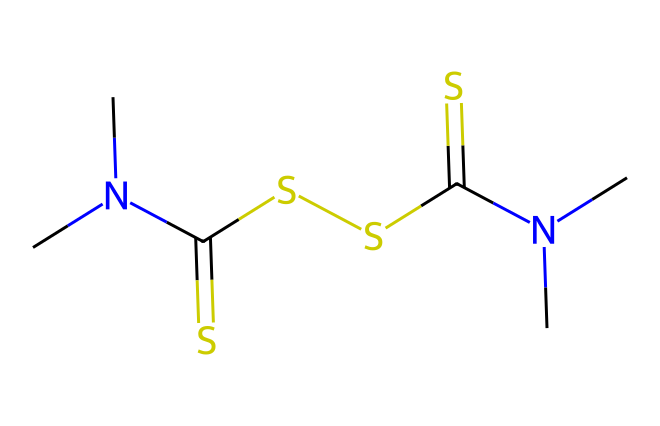What is the molecular formula of thiram? The SMILES representation can be analyzed to count the number of each type of atom present. The breakdown shows there are 8 carbon (C) atoms, 16 hydrogen (H) atoms, 4 sulfur (S) atoms, and 2 nitrogen (N) atoms. Putting this together, the molecular formula is C8H16N2S4.
Answer: C8H16N2S4 How many sulfur atoms are present in thiram? By inspecting the SMILES representation, we can see the "S" symbols appear four times, indicating the presence of four sulfur atoms in the molecule.
Answer: 4 What type of functional groups are present in thiram? The structure can be analyzed to identify functional groups; the presence of thiocarbamates and thioamides can be inferred from the arrangement of sulfur (S) and nitrogen (N) atoms bonded to carbon (C). This indicates the presence of functional groups related to fungicides.
Answer: thiocarbamate, thioamide How many nitrogen atoms are there in thiram's structure? In the SMILES representation, the "N" characters indicate nitrogen atoms. Counting them gives a total of two nitrogen atoms in the molecule.
Answer: 2 Which part of thiram's structure is responsible for its fungicidal activity? The active fungicidal properties are usually attributed to the thiocarbonyl group (C=S), which is present in the structure. This functionality reacts with biological targets in fungi, disrupting their growth.
Answer: thiocarbonyl group What is the overall charge of thiram? The SMILES representation does not indicate any charges (no "+" or "-" signs), which means the overall molecule is uncharged and neutral in its molecular structure.
Answer: neutral What is the significance of using thiram as a seed treatment? Thiram, being a fungicide, is significant because it prevents seedborne diseases and promotes healthier plant growth by protecting seeds from pathogenic fungi. This improves seed germination and crop yields.
Answer: prevents diseases 